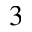<formula> <loc_0><loc_0><loc_500><loc_500>_ { 3 }</formula> 